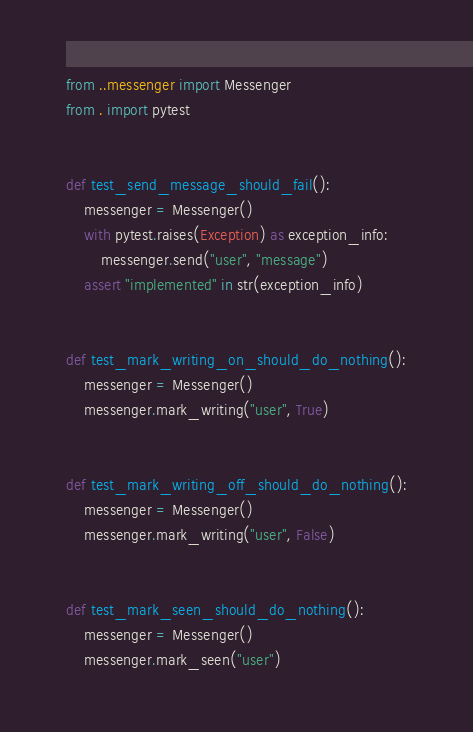Convert code to text. <code><loc_0><loc_0><loc_500><loc_500><_Python_>from ..messenger import Messenger
from . import pytest


def test_send_message_should_fail():
    messenger = Messenger()
    with pytest.raises(Exception) as exception_info:
        messenger.send("user", "message")
    assert "implemented" in str(exception_info)


def test_mark_writing_on_should_do_nothing():
    messenger = Messenger()
    messenger.mark_writing("user", True)


def test_mark_writing_off_should_do_nothing():
    messenger = Messenger()
    messenger.mark_writing("user", False)


def test_mark_seen_should_do_nothing():
    messenger = Messenger()
    messenger.mark_seen("user")
</code> 